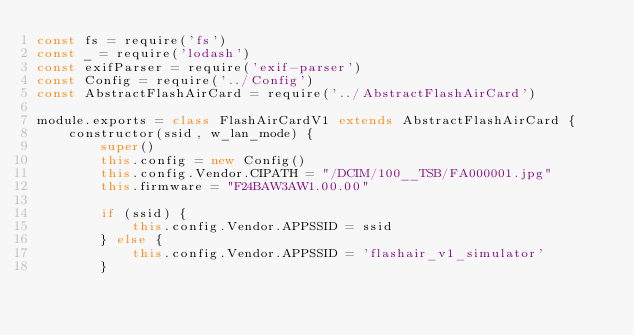<code> <loc_0><loc_0><loc_500><loc_500><_JavaScript_>const fs = require('fs')
const _ = require('lodash')
const exifParser = require('exif-parser')
const Config = require('../Config')
const AbstractFlashAirCard = require('../AbstractFlashAirCard')

module.exports = class FlashAirCardV1 extends AbstractFlashAirCard {
	constructor(ssid, w_lan_mode) {
		super()
		this.config = new Config()
		this.config.Vendor.CIPATH = "/DCIM/100__TSB/FA000001.jpg"
		this.firmware = "F24BAW3AW1.00.00"

		if (ssid) {
			this.config.Vendor.APPSSID = ssid
		} else {
			this.config.Vendor.APPSSID = 'flashair_v1_simulator'
		}</code> 